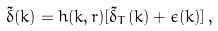Convert formula to latex. <formula><loc_0><loc_0><loc_500><loc_500>\tilde { \delta } ( k ) = h ( k , r ) [ \tilde { \delta } _ { T } ( k ) + \epsilon ( k ) ] \, ,</formula> 